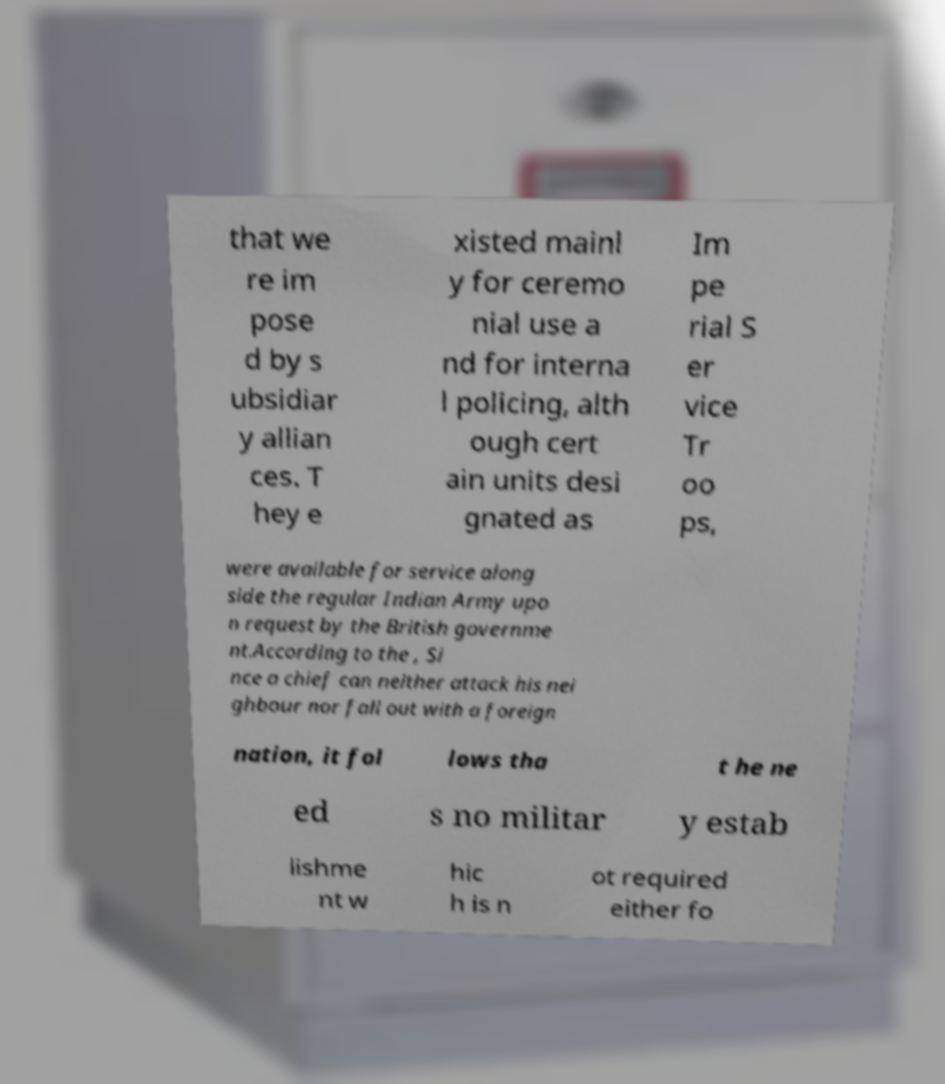I need the written content from this picture converted into text. Can you do that? that we re im pose d by s ubsidiar y allian ces. T hey e xisted mainl y for ceremo nial use a nd for interna l policing, alth ough cert ain units desi gnated as Im pe rial S er vice Tr oo ps, were available for service along side the regular Indian Army upo n request by the British governme nt.According to the , Si nce a chief can neither attack his nei ghbour nor fall out with a foreign nation, it fol lows tha t he ne ed s no militar y estab lishme nt w hic h is n ot required either fo 